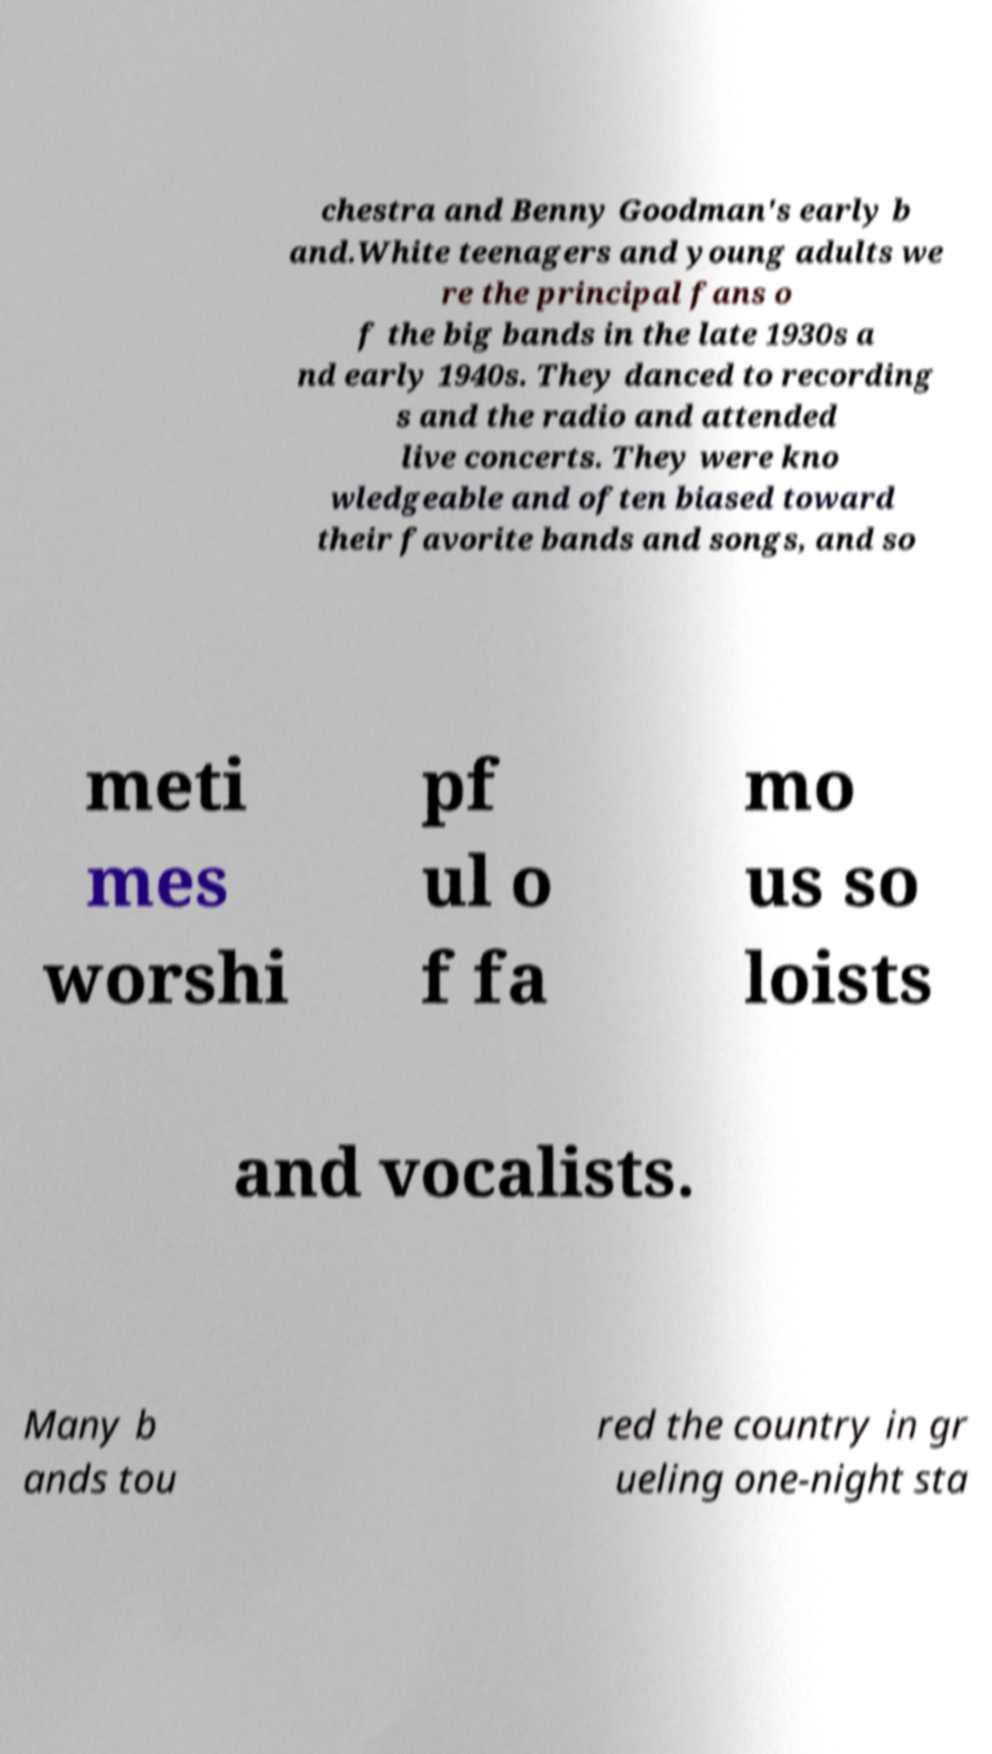There's text embedded in this image that I need extracted. Can you transcribe it verbatim? chestra and Benny Goodman's early b and.White teenagers and young adults we re the principal fans o f the big bands in the late 1930s a nd early 1940s. They danced to recording s and the radio and attended live concerts. They were kno wledgeable and often biased toward their favorite bands and songs, and so meti mes worshi pf ul o f fa mo us so loists and vocalists. Many b ands tou red the country in gr ueling one-night sta 